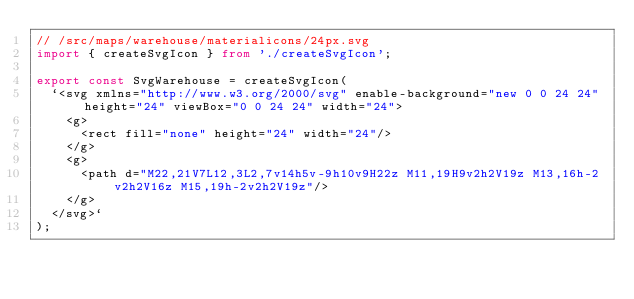<code> <loc_0><loc_0><loc_500><loc_500><_TypeScript_>// /src/maps/warehouse/materialicons/24px.svg
import { createSvgIcon } from './createSvgIcon';

export const SvgWarehouse = createSvgIcon(
  `<svg xmlns="http://www.w3.org/2000/svg" enable-background="new 0 0 24 24" height="24" viewBox="0 0 24 24" width="24">
    <g>
      <rect fill="none" height="24" width="24"/>
    </g>
    <g>
      <path d="M22,21V7L12,3L2,7v14h5v-9h10v9H22z M11,19H9v2h2V19z M13,16h-2v2h2V16z M15,19h-2v2h2V19z"/>
    </g>
  </svg>`
);

</code> 